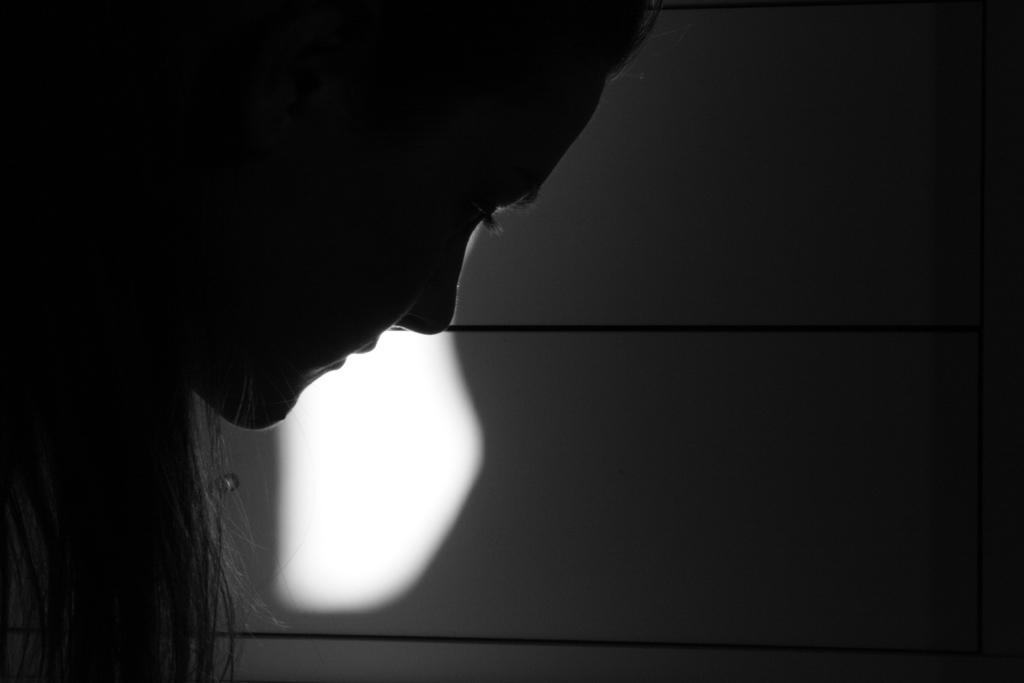Describe this image in one or two sentences. This image is a black and white image. In the background there is a wall. On the left side of the image there is a woman. 